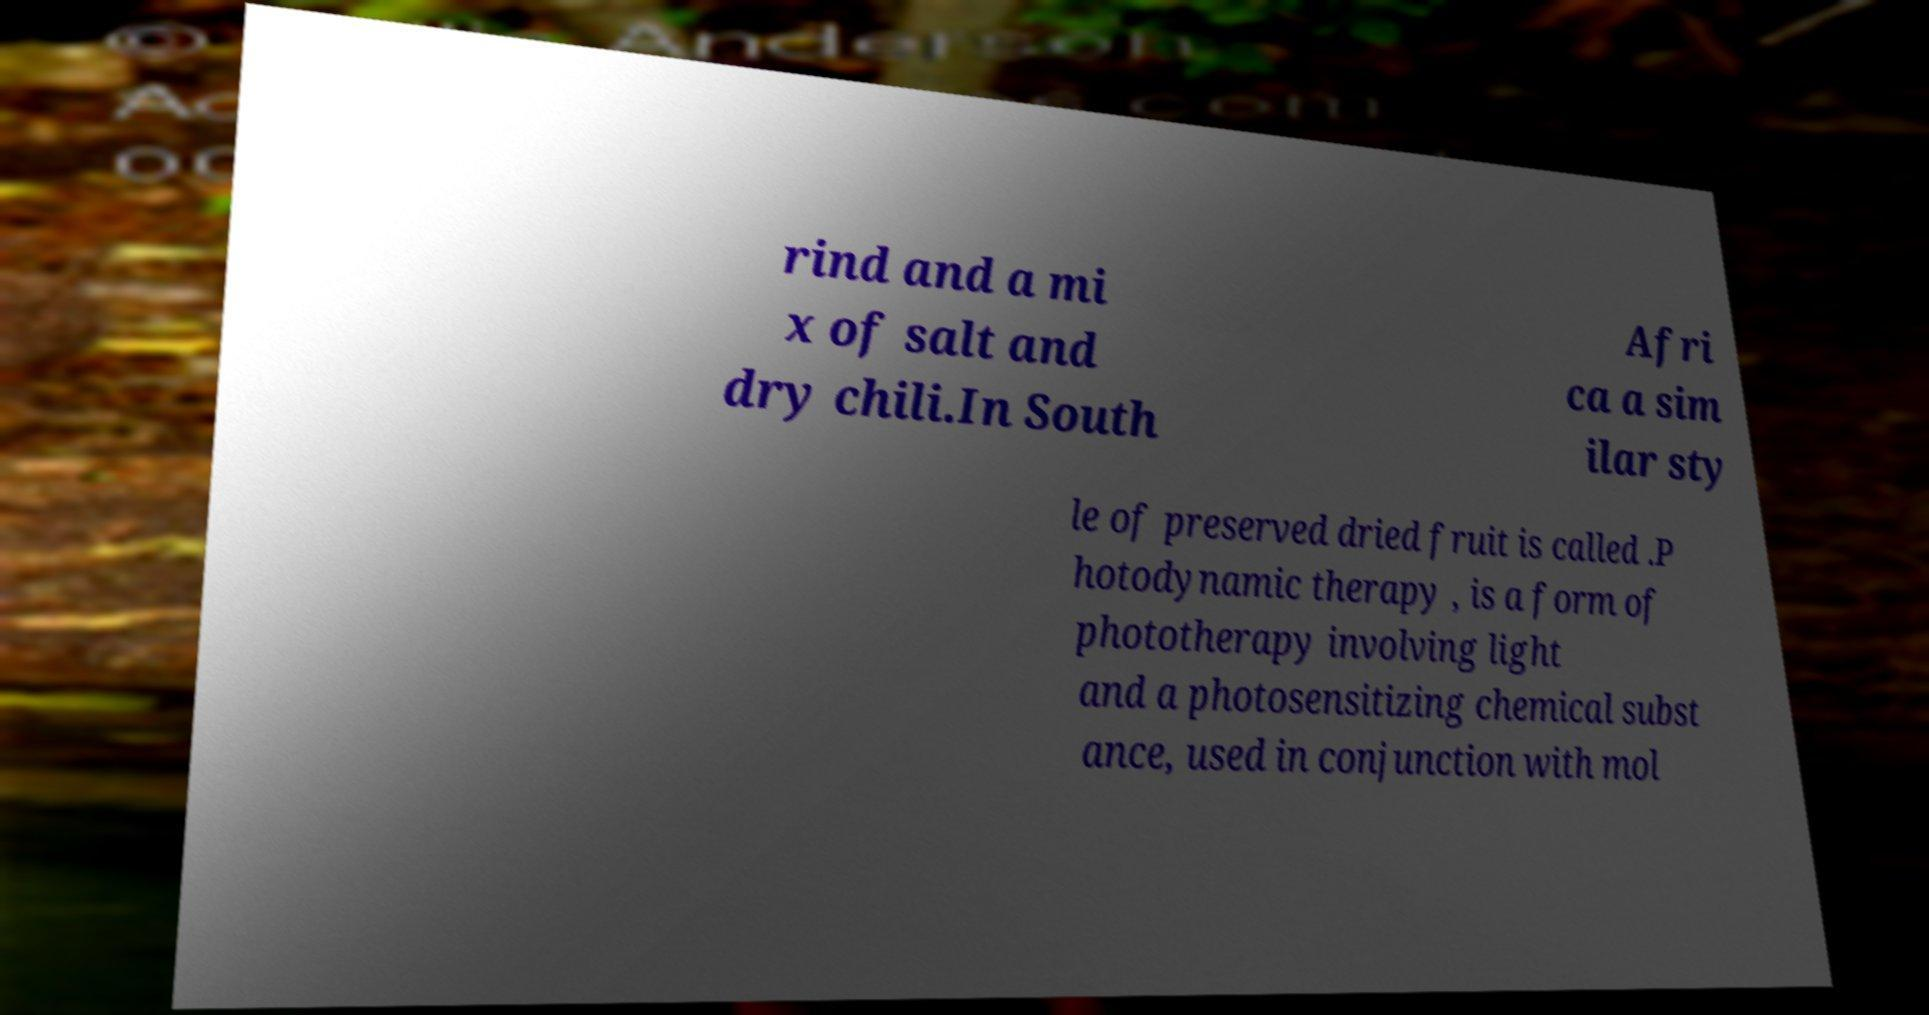What messages or text are displayed in this image? I need them in a readable, typed format. rind and a mi x of salt and dry chili.In South Afri ca a sim ilar sty le of preserved dried fruit is called .P hotodynamic therapy , is a form of phototherapy involving light and a photosensitizing chemical subst ance, used in conjunction with mol 